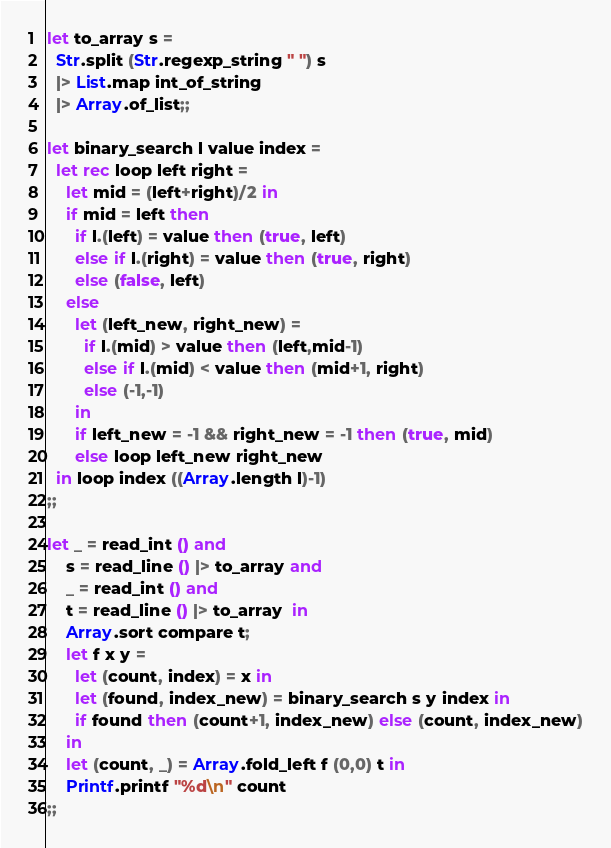<code> <loc_0><loc_0><loc_500><loc_500><_OCaml_>let to_array s =
  Str.split (Str.regexp_string " ") s
  |> List.map int_of_string
  |> Array.of_list;;

let binary_search l value index =
  let rec loop left right =
    let mid = (left+right)/2 in
    if mid = left then
      if l.(left) = value then (true, left)
      else if l.(right) = value then (true, right)
      else (false, left)
    else
      let (left_new, right_new) =
        if l.(mid) > value then (left,mid-1)
        else if l.(mid) < value then (mid+1, right)
        else (-1,-1)
      in
      if left_new = -1 && right_new = -1 then (true, mid)
      else loop left_new right_new
  in loop index ((Array.length l)-1)
;;

let _ = read_int () and
    s = read_line () |> to_array and
    _ = read_int () and
    t = read_line () |> to_array  in
    Array.sort compare t;
    let f x y =
      let (count, index) = x in
      let (found, index_new) = binary_search s y index in
      if found then (count+1, index_new) else (count, index_new)
    in
    let (count, _) = Array.fold_left f (0,0) t in
    Printf.printf "%d\n" count
;;</code> 